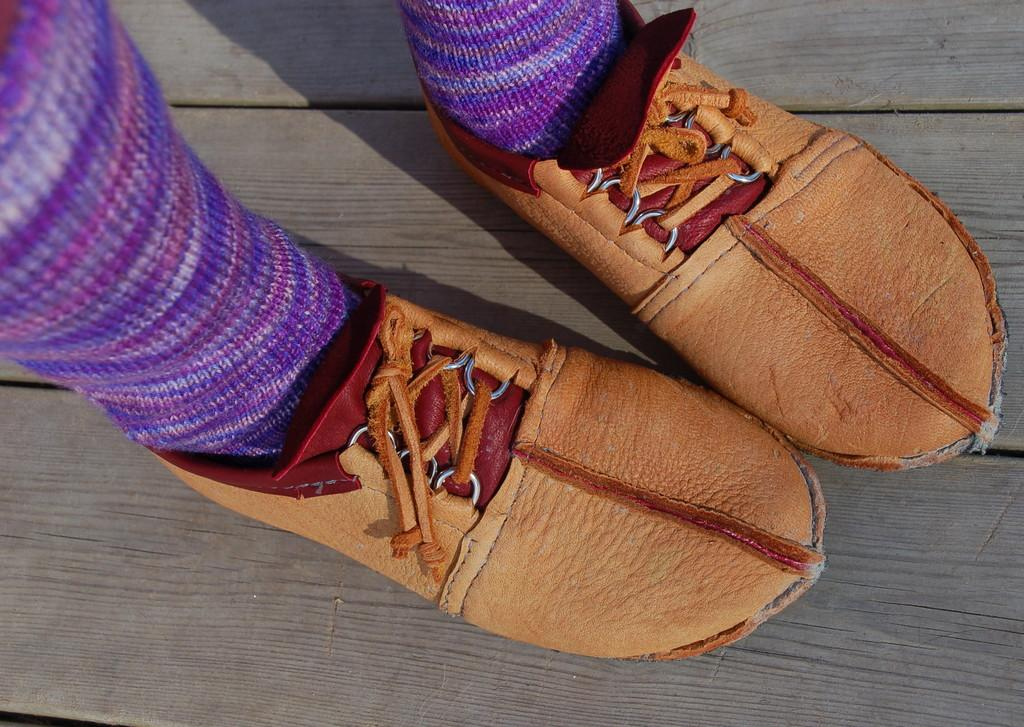What is the main subject of the image? There is a person standing in the image. What type of footwear is the person wearing? The person is wearing brown shoes. What color are the socks that the person is wearing? The person is wearing pink socks. What type of toy can be seen participating in the event in the image? There is no event or toy present in the image; it only features a person standing with brown shoes and pink socks. 